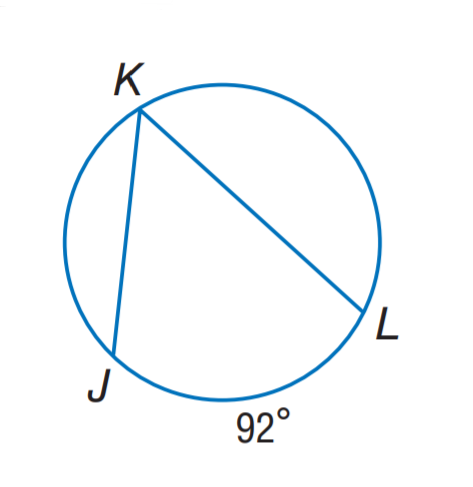Question: Find m \angle K.
Choices:
A. 46
B. 63
C. 69
D. 92
Answer with the letter. Answer: A 